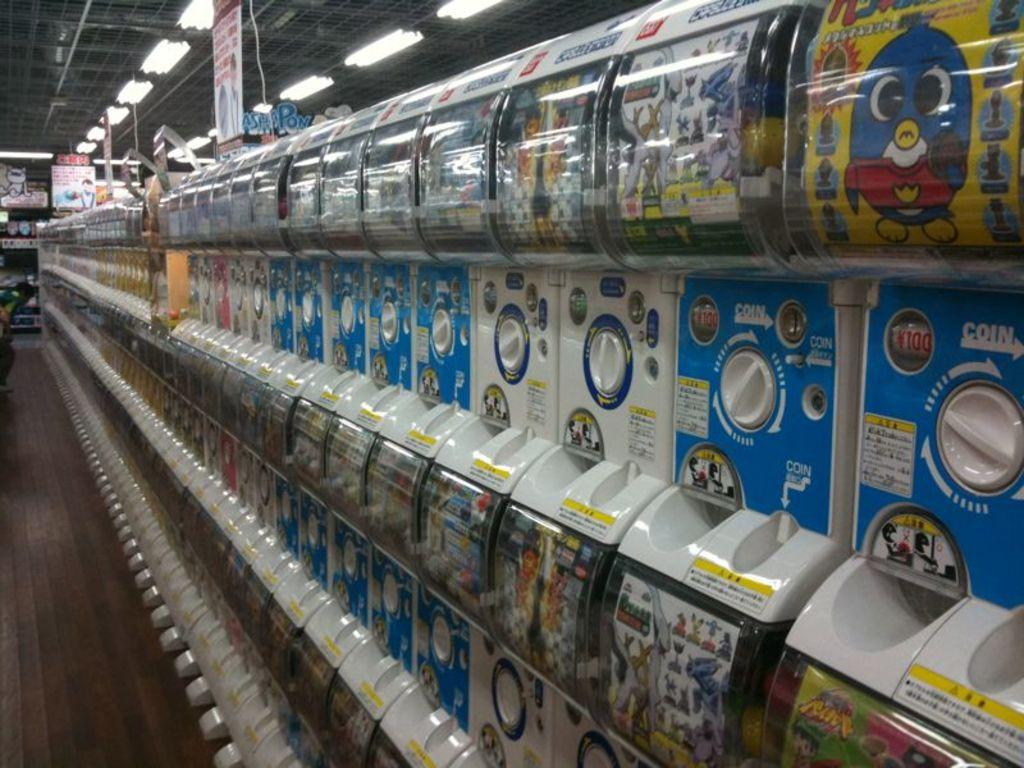<image>
Write a terse but informative summary of the picture. rows of coin machines with one of them that says 'coin' on it 